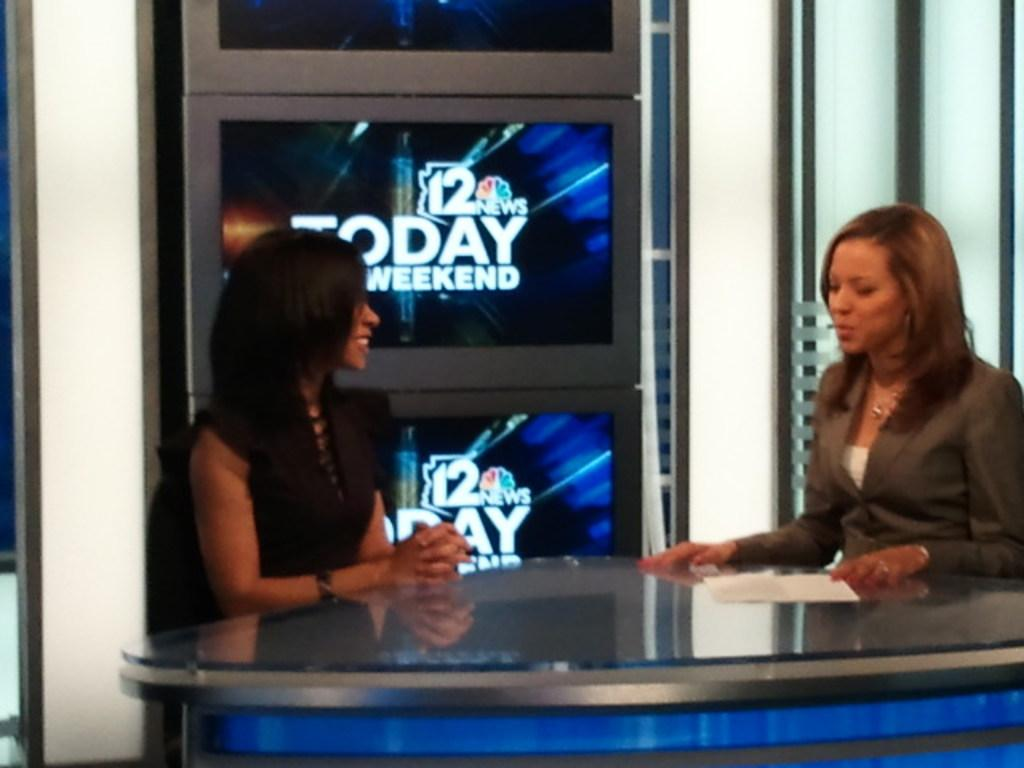<image>
Offer a succinct explanation of the picture presented. two women commentators at the channel 12 today weekend show 